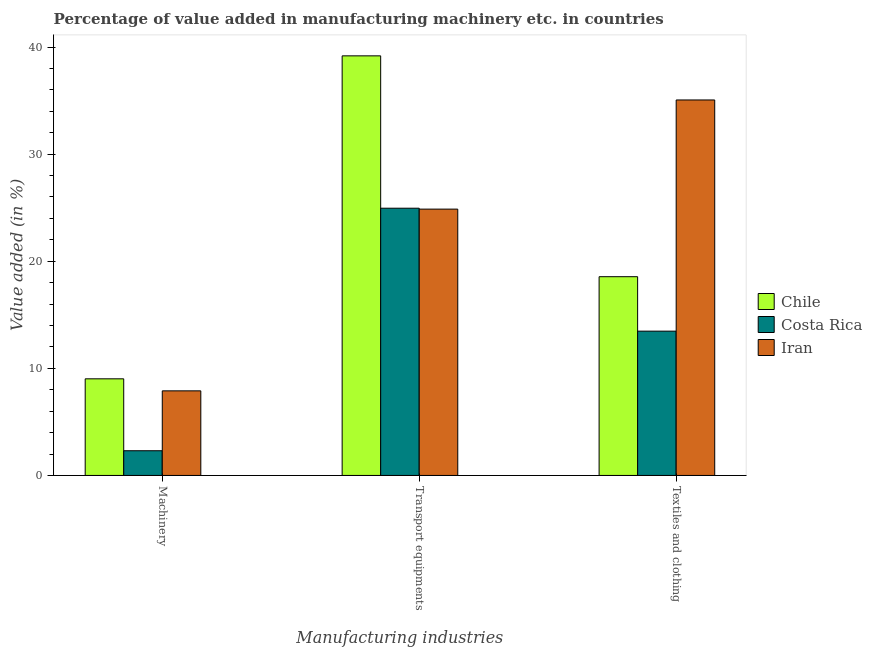How many groups of bars are there?
Offer a terse response. 3. Are the number of bars per tick equal to the number of legend labels?
Offer a very short reply. Yes. Are the number of bars on each tick of the X-axis equal?
Offer a terse response. Yes. How many bars are there on the 2nd tick from the right?
Ensure brevity in your answer.  3. What is the label of the 2nd group of bars from the left?
Provide a short and direct response. Transport equipments. What is the value added in manufacturing transport equipments in Chile?
Provide a short and direct response. 39.18. Across all countries, what is the maximum value added in manufacturing transport equipments?
Your answer should be compact. 39.18. Across all countries, what is the minimum value added in manufacturing textile and clothing?
Ensure brevity in your answer.  13.47. In which country was the value added in manufacturing machinery minimum?
Offer a very short reply. Costa Rica. What is the total value added in manufacturing textile and clothing in the graph?
Your response must be concise. 67.09. What is the difference between the value added in manufacturing textile and clothing in Costa Rica and that in Iran?
Ensure brevity in your answer.  -21.59. What is the difference between the value added in manufacturing machinery in Costa Rica and the value added in manufacturing transport equipments in Chile?
Your answer should be compact. -36.87. What is the average value added in manufacturing textile and clothing per country?
Provide a short and direct response. 22.36. What is the difference between the value added in manufacturing transport equipments and value added in manufacturing machinery in Costa Rica?
Ensure brevity in your answer.  22.64. In how many countries, is the value added in manufacturing transport equipments greater than 16 %?
Give a very brief answer. 3. What is the ratio of the value added in manufacturing textile and clothing in Costa Rica to that in Chile?
Ensure brevity in your answer.  0.73. Is the value added in manufacturing textile and clothing in Chile less than that in Costa Rica?
Provide a succinct answer. No. Is the difference between the value added in manufacturing transport equipments in Iran and Costa Rica greater than the difference between the value added in manufacturing textile and clothing in Iran and Costa Rica?
Offer a terse response. No. What is the difference between the highest and the second highest value added in manufacturing textile and clothing?
Offer a very short reply. 16.5. What is the difference between the highest and the lowest value added in manufacturing machinery?
Provide a short and direct response. 6.71. What does the 3rd bar from the left in Machinery represents?
Your response must be concise. Iran. Are all the bars in the graph horizontal?
Offer a very short reply. No. How many countries are there in the graph?
Your response must be concise. 3. What is the difference between two consecutive major ticks on the Y-axis?
Keep it short and to the point. 10. Are the values on the major ticks of Y-axis written in scientific E-notation?
Give a very brief answer. No. Does the graph contain grids?
Make the answer very short. No. Where does the legend appear in the graph?
Provide a short and direct response. Center right. How are the legend labels stacked?
Ensure brevity in your answer.  Vertical. What is the title of the graph?
Keep it short and to the point. Percentage of value added in manufacturing machinery etc. in countries. What is the label or title of the X-axis?
Offer a terse response. Manufacturing industries. What is the label or title of the Y-axis?
Offer a very short reply. Value added (in %). What is the Value added (in %) of Chile in Machinery?
Give a very brief answer. 9.02. What is the Value added (in %) of Costa Rica in Machinery?
Keep it short and to the point. 2.31. What is the Value added (in %) in Iran in Machinery?
Keep it short and to the point. 7.9. What is the Value added (in %) in Chile in Transport equipments?
Give a very brief answer. 39.18. What is the Value added (in %) of Costa Rica in Transport equipments?
Your answer should be compact. 24.95. What is the Value added (in %) in Iran in Transport equipments?
Offer a terse response. 24.87. What is the Value added (in %) of Chile in Textiles and clothing?
Provide a short and direct response. 18.56. What is the Value added (in %) of Costa Rica in Textiles and clothing?
Give a very brief answer. 13.47. What is the Value added (in %) in Iran in Textiles and clothing?
Provide a succinct answer. 35.06. Across all Manufacturing industries, what is the maximum Value added (in %) of Chile?
Offer a terse response. 39.18. Across all Manufacturing industries, what is the maximum Value added (in %) of Costa Rica?
Ensure brevity in your answer.  24.95. Across all Manufacturing industries, what is the maximum Value added (in %) in Iran?
Give a very brief answer. 35.06. Across all Manufacturing industries, what is the minimum Value added (in %) in Chile?
Offer a terse response. 9.02. Across all Manufacturing industries, what is the minimum Value added (in %) in Costa Rica?
Provide a short and direct response. 2.31. Across all Manufacturing industries, what is the minimum Value added (in %) of Iran?
Offer a very short reply. 7.9. What is the total Value added (in %) in Chile in the graph?
Make the answer very short. 66.75. What is the total Value added (in %) in Costa Rica in the graph?
Ensure brevity in your answer.  40.73. What is the total Value added (in %) in Iran in the graph?
Give a very brief answer. 67.82. What is the difference between the Value added (in %) of Chile in Machinery and that in Transport equipments?
Offer a terse response. -30.15. What is the difference between the Value added (in %) of Costa Rica in Machinery and that in Transport equipments?
Give a very brief answer. -22.64. What is the difference between the Value added (in %) in Iran in Machinery and that in Transport equipments?
Ensure brevity in your answer.  -16.97. What is the difference between the Value added (in %) of Chile in Machinery and that in Textiles and clothing?
Your response must be concise. -9.54. What is the difference between the Value added (in %) in Costa Rica in Machinery and that in Textiles and clothing?
Keep it short and to the point. -11.17. What is the difference between the Value added (in %) in Iran in Machinery and that in Textiles and clothing?
Offer a very short reply. -27.16. What is the difference between the Value added (in %) in Chile in Transport equipments and that in Textiles and clothing?
Offer a very short reply. 20.62. What is the difference between the Value added (in %) in Costa Rica in Transport equipments and that in Textiles and clothing?
Offer a terse response. 11.48. What is the difference between the Value added (in %) in Iran in Transport equipments and that in Textiles and clothing?
Offer a very short reply. -10.19. What is the difference between the Value added (in %) in Chile in Machinery and the Value added (in %) in Costa Rica in Transport equipments?
Your answer should be compact. -15.93. What is the difference between the Value added (in %) in Chile in Machinery and the Value added (in %) in Iran in Transport equipments?
Offer a terse response. -15.85. What is the difference between the Value added (in %) in Costa Rica in Machinery and the Value added (in %) in Iran in Transport equipments?
Your response must be concise. -22.56. What is the difference between the Value added (in %) of Chile in Machinery and the Value added (in %) of Costa Rica in Textiles and clothing?
Your response must be concise. -4.45. What is the difference between the Value added (in %) of Chile in Machinery and the Value added (in %) of Iran in Textiles and clothing?
Give a very brief answer. -26.04. What is the difference between the Value added (in %) in Costa Rica in Machinery and the Value added (in %) in Iran in Textiles and clothing?
Your response must be concise. -32.75. What is the difference between the Value added (in %) in Chile in Transport equipments and the Value added (in %) in Costa Rica in Textiles and clothing?
Provide a succinct answer. 25.7. What is the difference between the Value added (in %) of Chile in Transport equipments and the Value added (in %) of Iran in Textiles and clothing?
Provide a short and direct response. 4.12. What is the difference between the Value added (in %) in Costa Rica in Transport equipments and the Value added (in %) in Iran in Textiles and clothing?
Your answer should be very brief. -10.11. What is the average Value added (in %) in Chile per Manufacturing industries?
Give a very brief answer. 22.25. What is the average Value added (in %) of Costa Rica per Manufacturing industries?
Provide a short and direct response. 13.58. What is the average Value added (in %) in Iran per Manufacturing industries?
Keep it short and to the point. 22.61. What is the difference between the Value added (in %) in Chile and Value added (in %) in Costa Rica in Machinery?
Ensure brevity in your answer.  6.71. What is the difference between the Value added (in %) in Chile and Value added (in %) in Iran in Machinery?
Provide a succinct answer. 1.12. What is the difference between the Value added (in %) in Costa Rica and Value added (in %) in Iran in Machinery?
Your response must be concise. -5.59. What is the difference between the Value added (in %) of Chile and Value added (in %) of Costa Rica in Transport equipments?
Your answer should be compact. 14.22. What is the difference between the Value added (in %) of Chile and Value added (in %) of Iran in Transport equipments?
Offer a terse response. 14.31. What is the difference between the Value added (in %) in Costa Rica and Value added (in %) in Iran in Transport equipments?
Give a very brief answer. 0.08. What is the difference between the Value added (in %) of Chile and Value added (in %) of Costa Rica in Textiles and clothing?
Give a very brief answer. 5.08. What is the difference between the Value added (in %) of Chile and Value added (in %) of Iran in Textiles and clothing?
Provide a short and direct response. -16.5. What is the difference between the Value added (in %) in Costa Rica and Value added (in %) in Iran in Textiles and clothing?
Offer a very short reply. -21.59. What is the ratio of the Value added (in %) of Chile in Machinery to that in Transport equipments?
Your answer should be compact. 0.23. What is the ratio of the Value added (in %) in Costa Rica in Machinery to that in Transport equipments?
Your answer should be very brief. 0.09. What is the ratio of the Value added (in %) in Iran in Machinery to that in Transport equipments?
Your answer should be compact. 0.32. What is the ratio of the Value added (in %) in Chile in Machinery to that in Textiles and clothing?
Offer a terse response. 0.49. What is the ratio of the Value added (in %) of Costa Rica in Machinery to that in Textiles and clothing?
Provide a short and direct response. 0.17. What is the ratio of the Value added (in %) in Iran in Machinery to that in Textiles and clothing?
Keep it short and to the point. 0.23. What is the ratio of the Value added (in %) in Chile in Transport equipments to that in Textiles and clothing?
Keep it short and to the point. 2.11. What is the ratio of the Value added (in %) of Costa Rica in Transport equipments to that in Textiles and clothing?
Give a very brief answer. 1.85. What is the ratio of the Value added (in %) of Iran in Transport equipments to that in Textiles and clothing?
Provide a short and direct response. 0.71. What is the difference between the highest and the second highest Value added (in %) in Chile?
Your response must be concise. 20.62. What is the difference between the highest and the second highest Value added (in %) in Costa Rica?
Provide a succinct answer. 11.48. What is the difference between the highest and the second highest Value added (in %) of Iran?
Make the answer very short. 10.19. What is the difference between the highest and the lowest Value added (in %) in Chile?
Provide a succinct answer. 30.15. What is the difference between the highest and the lowest Value added (in %) of Costa Rica?
Your answer should be compact. 22.64. What is the difference between the highest and the lowest Value added (in %) in Iran?
Keep it short and to the point. 27.16. 